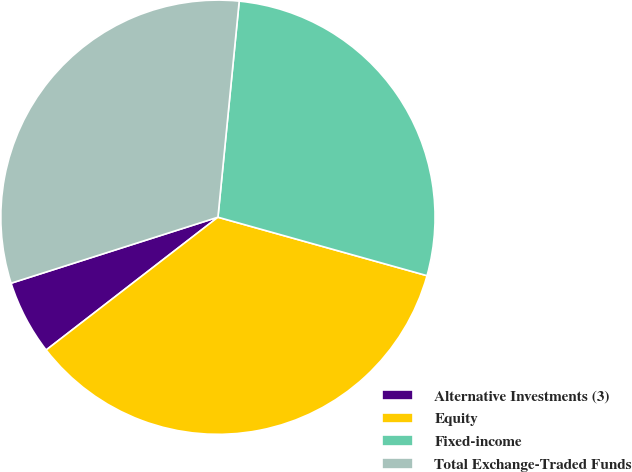<chart> <loc_0><loc_0><loc_500><loc_500><pie_chart><fcel>Alternative Investments (3)<fcel>Equity<fcel>Fixed-income<fcel>Total Exchange-Traded Funds<nl><fcel>5.56%<fcel>35.19%<fcel>27.78%<fcel>31.48%<nl></chart> 